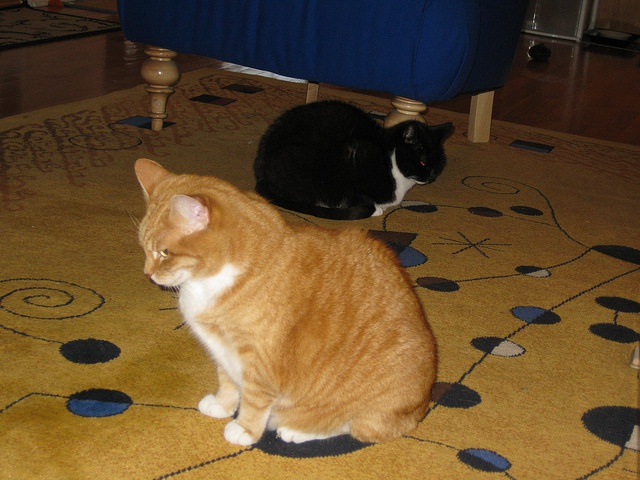Describe the objects in this image and their specific colors. I can see cat in black, olive, and tan tones, bench in black, navy, olive, and maroon tones, and cat in black, darkgray, and gray tones in this image. 